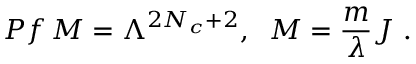Convert formula to latex. <formula><loc_0><loc_0><loc_500><loc_500>P f \, M = \Lambda ^ { 2 N _ { c } + 2 } , \, M = \frac { m } { \lambda } J \ .</formula> 